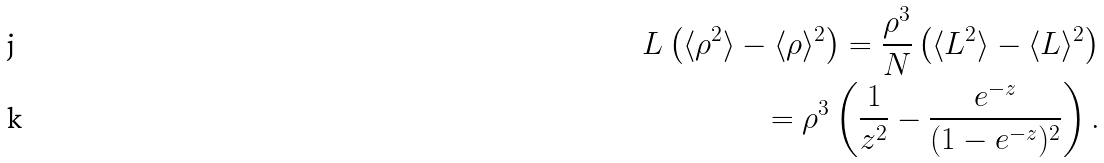<formula> <loc_0><loc_0><loc_500><loc_500>L \left ( \langle \rho ^ { 2 } \rangle - \langle \rho \rangle ^ { 2 } \right ) = \frac { \rho ^ { 3 } } { N } \left ( \langle L ^ { 2 } \rangle - \langle L \rangle ^ { 2 } \right ) \\ = \rho ^ { 3 } \left ( \frac { 1 } { z ^ { 2 } } - \frac { e ^ { - z } } { ( 1 - e ^ { - z } ) ^ { 2 } } \right ) .</formula> 